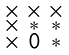Convert formula to latex. <formula><loc_0><loc_0><loc_500><loc_500>\begin{smallmatrix} \times & \times & \times \\ \times & * & * \\ \times & 0 & * \\ \end{smallmatrix}</formula> 